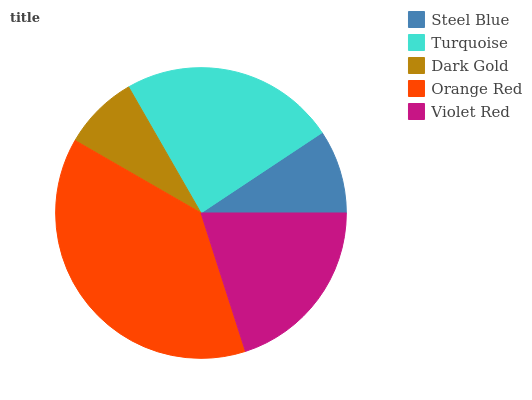Is Dark Gold the minimum?
Answer yes or no. Yes. Is Orange Red the maximum?
Answer yes or no. Yes. Is Turquoise the minimum?
Answer yes or no. No. Is Turquoise the maximum?
Answer yes or no. No. Is Turquoise greater than Steel Blue?
Answer yes or no. Yes. Is Steel Blue less than Turquoise?
Answer yes or no. Yes. Is Steel Blue greater than Turquoise?
Answer yes or no. No. Is Turquoise less than Steel Blue?
Answer yes or no. No. Is Violet Red the high median?
Answer yes or no. Yes. Is Violet Red the low median?
Answer yes or no. Yes. Is Steel Blue the high median?
Answer yes or no. No. Is Dark Gold the low median?
Answer yes or no. No. 